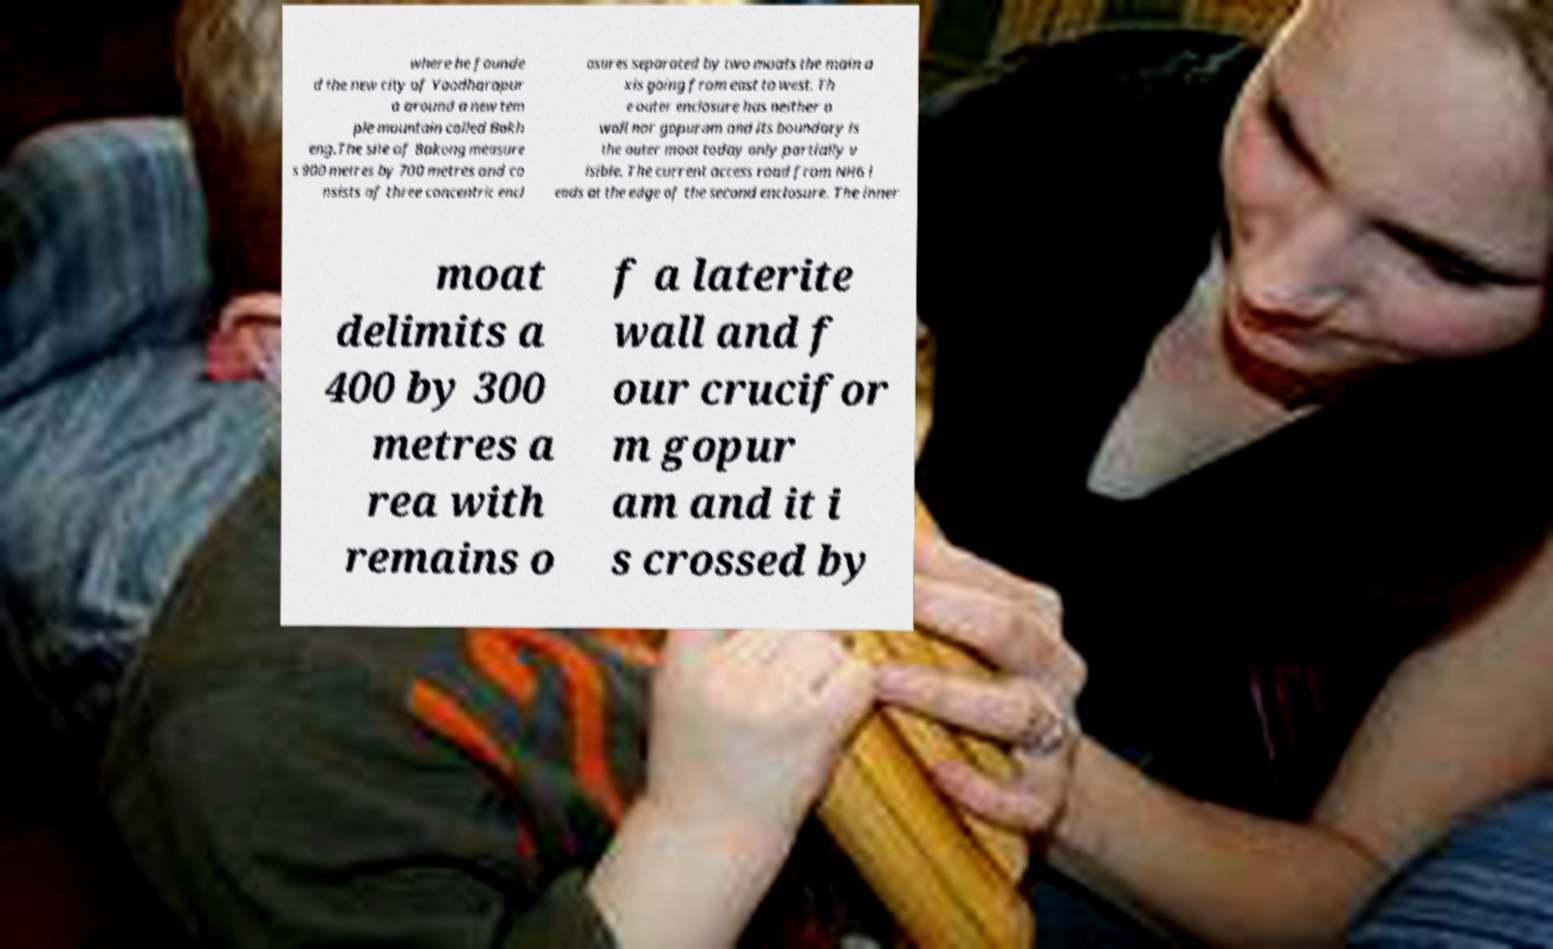Can you read and provide the text displayed in the image?This photo seems to have some interesting text. Can you extract and type it out for me? where he founde d the new city of Yaodharapur a around a new tem ple mountain called Bakh eng.The site of Bakong measure s 900 metres by 700 metres and co nsists of three concentric encl osures separated by two moats the main a xis going from east to west. Th e outer enclosure has neither a wall nor gopuram and its boundary is the outer moat today only partially v isible. The current access road from NH6 l eads at the edge of the second enclosure. The inner moat delimits a 400 by 300 metres a rea with remains o f a laterite wall and f our crucifor m gopur am and it i s crossed by 